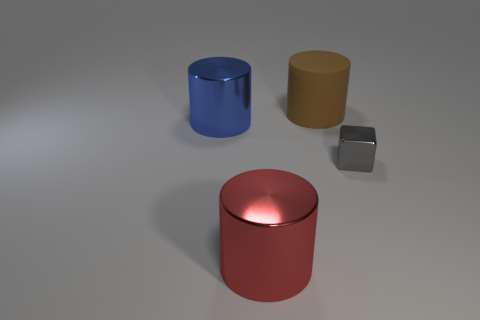Is there anything else that has the same material as the large red cylinder?
Offer a very short reply. Yes. Is the shape of the metal object behind the tiny gray shiny object the same as  the small gray object?
Give a very brief answer. No. The rubber object has what color?
Offer a terse response. Brown. Are there any gray matte cylinders?
Give a very brief answer. No. What size is the red thing that is the same material as the big blue cylinder?
Make the answer very short. Large. There is a shiny object right of the metallic cylinder that is right of the large metallic cylinder behind the small gray cube; what shape is it?
Make the answer very short. Cube. Is the number of gray shiny objects that are behind the large brown cylinder the same as the number of red shiny balls?
Make the answer very short. Yes. Is the shape of the big brown rubber thing the same as the big red thing?
Keep it short and to the point. Yes. What number of objects are objects that are behind the tiny gray thing or blue cylinders?
Offer a terse response. 2. Are there an equal number of rubber things in front of the large red object and large blue shiny cylinders that are left of the large rubber thing?
Make the answer very short. No. 